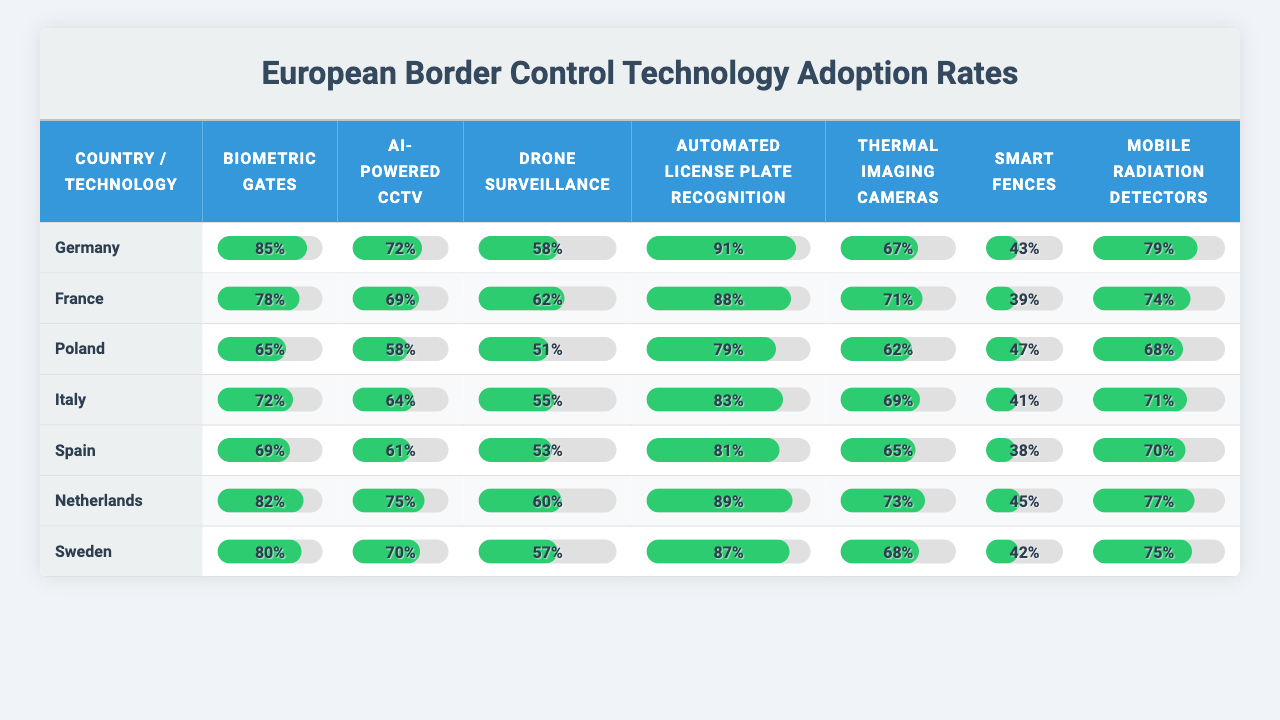What is the adoption rate of Biometric Gates in Germany? The table shows that the adoption rate of Biometric Gates in Germany is explicitly listed as 85%.
Answer: 85% Which country has the highest adoption rate for Automated License Plate Recognition? By examining the table, I see that Germany has the highest adoption rate for Automated License Plate Recognition at 91%.
Answer: Germany What is the average adoption rate of Drone Surveillance across all listed countries? To find the average, I add up the adoption rates for Drone Surveillance (58 + 62 + 51 + 55 + 53 + 60 + 57) = 416, and there are 7 countries, so the average is 416/7 = 59.43.
Answer: 59.43 Which technology has the lowest adoption rate in France? In France, the technology with the lowest adoption rate is Smart Fences at 39%.
Answer: Smart Fences Is the adoption rate for Mobile Radiation Detectors in Spain greater than the adoption rate in Italy? In the table, Spain has a Mobile Radiation Detector adoption rate of 70%, while Italy has 71%. Since 70% is not greater than 71%, the answer is no.
Answer: No How much higher is the adoption rate of Thermal Imaging Cameras in the Netherlands compared to Poland? The Netherlands has a 73% adoption rate for Thermal Imaging Cameras, and Poland has 62%. The difference is 73 - 62 = 11%.
Answer: 11% Which two countries have the closest adoption rates for AI-Powered CCTV? Looking at the table, France (69%) and Poland (58%) are close, but Germany (72%) and the Netherlands (75%) are also relatively close. The closest pair appears to be France and Poland.
Answer: France and Poland What is the total adoption rate for Biometric Gates across all countries? Adding the adoption rates for Biometric Gates (85 + 78 + 65 + 72 + 69 + 82 + 80) gives a total of 531.
Answer: 531 Is there a technology where all countries have an adoption rate above 50%? By checking the table, all countries have adoption rates for Biometric Gates and Automated License Plate Recognition above 50%. Therefore, yes, there are two technologies that meet this criterion.
Answer: Yes Which country has the lowest overall adoption rates for the listed technologies? By comparing the total adoption rates, Poland has the lowest scores across technologies when added together. Its total is 421, making it the lowest.
Answer: Poland 